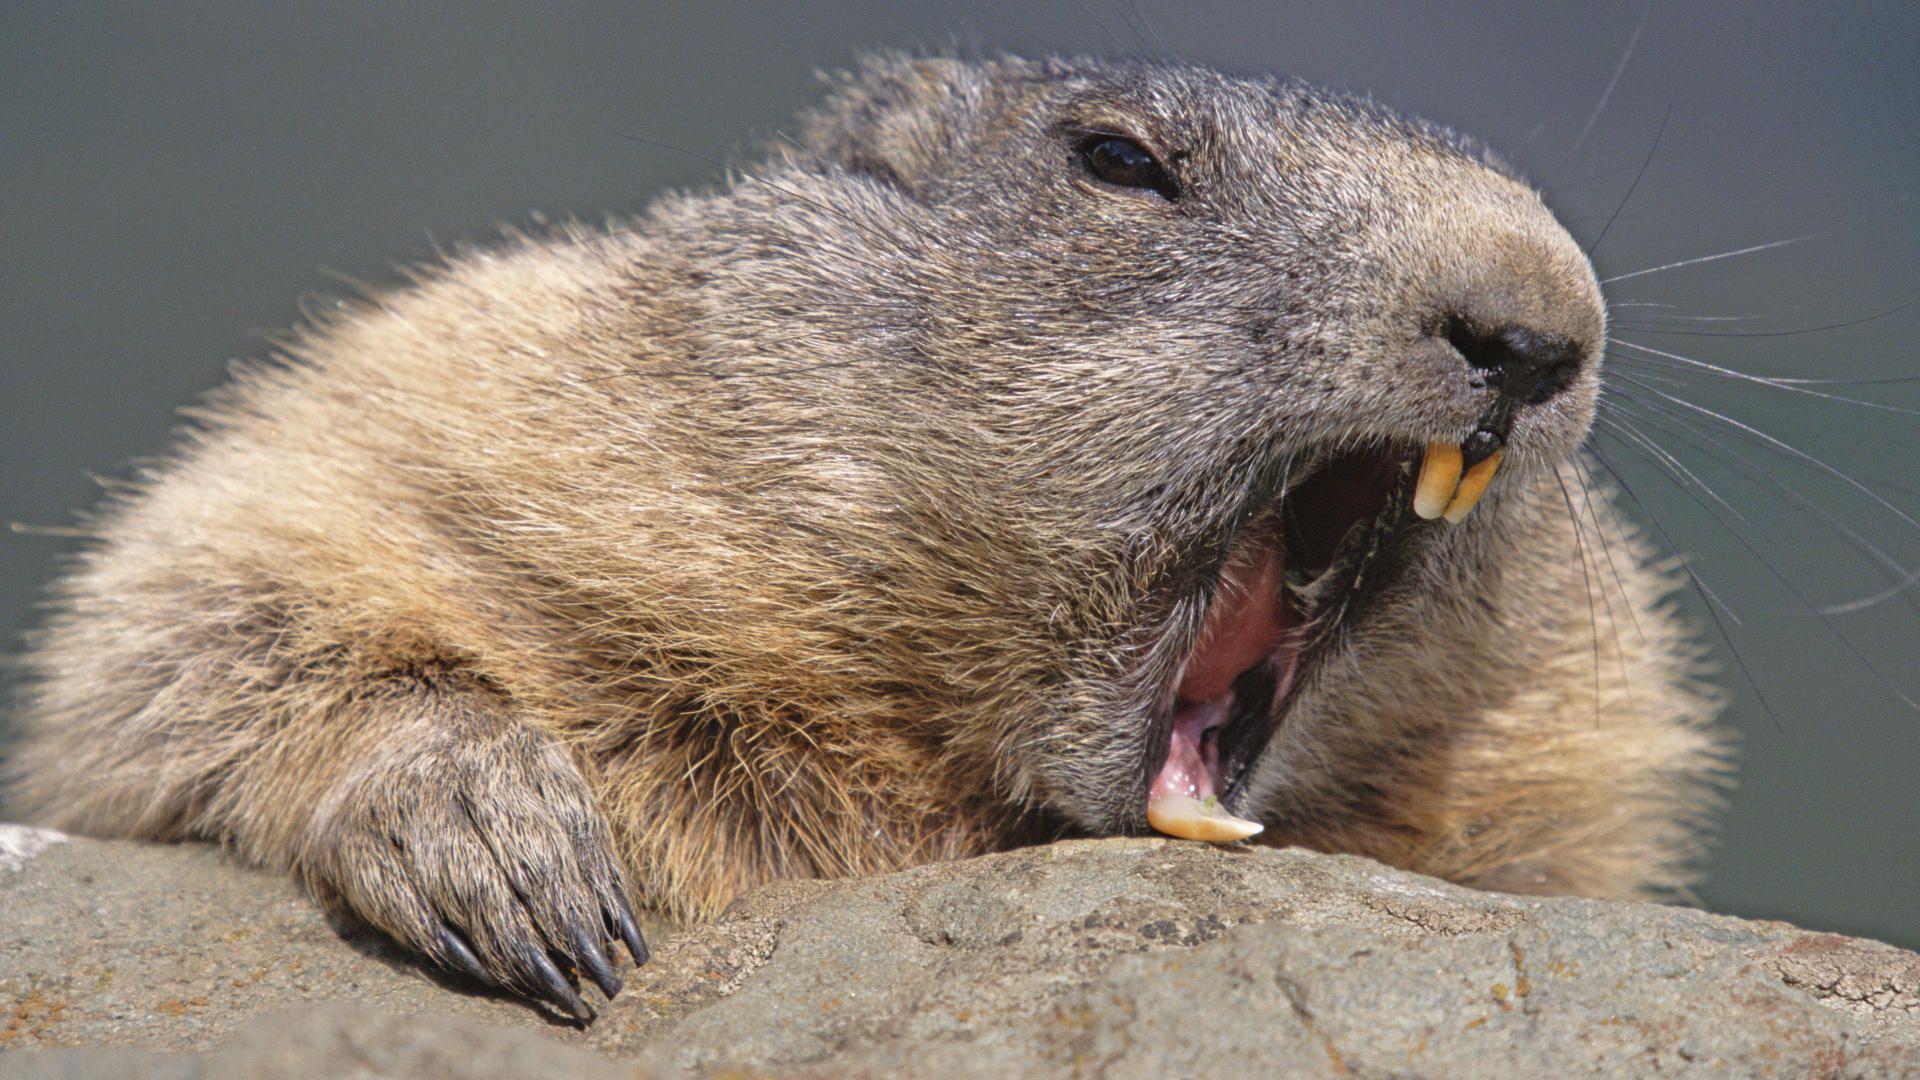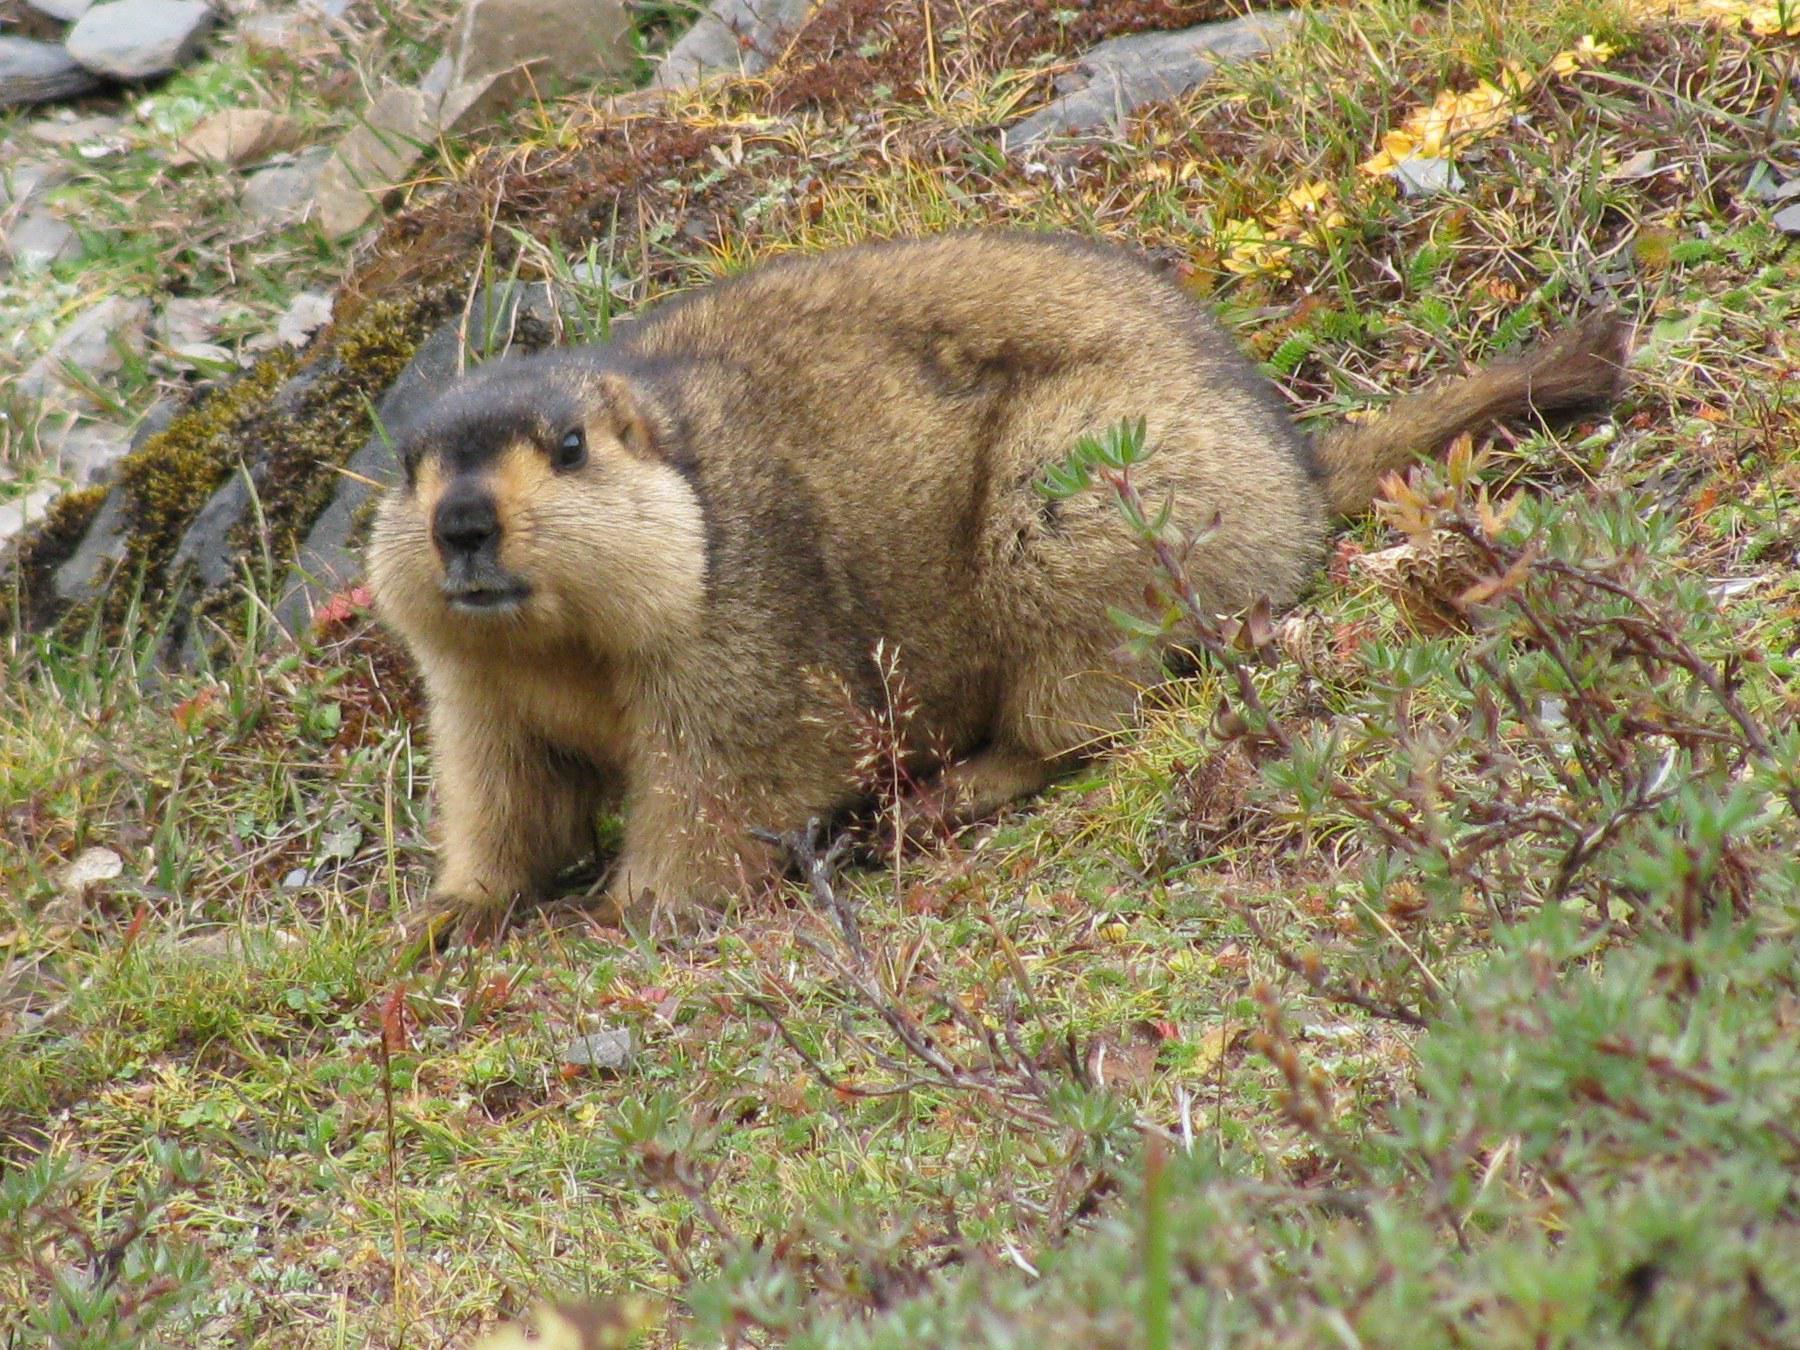The first image is the image on the left, the second image is the image on the right. For the images shown, is this caption "There are 3 prairie dogs with at least 2 of them standing upright." true? Answer yes or no. No. The first image is the image on the left, the second image is the image on the right. Assess this claim about the two images: "there is a gopher sitting with food in its hands". Correct or not? Answer yes or no. No. 